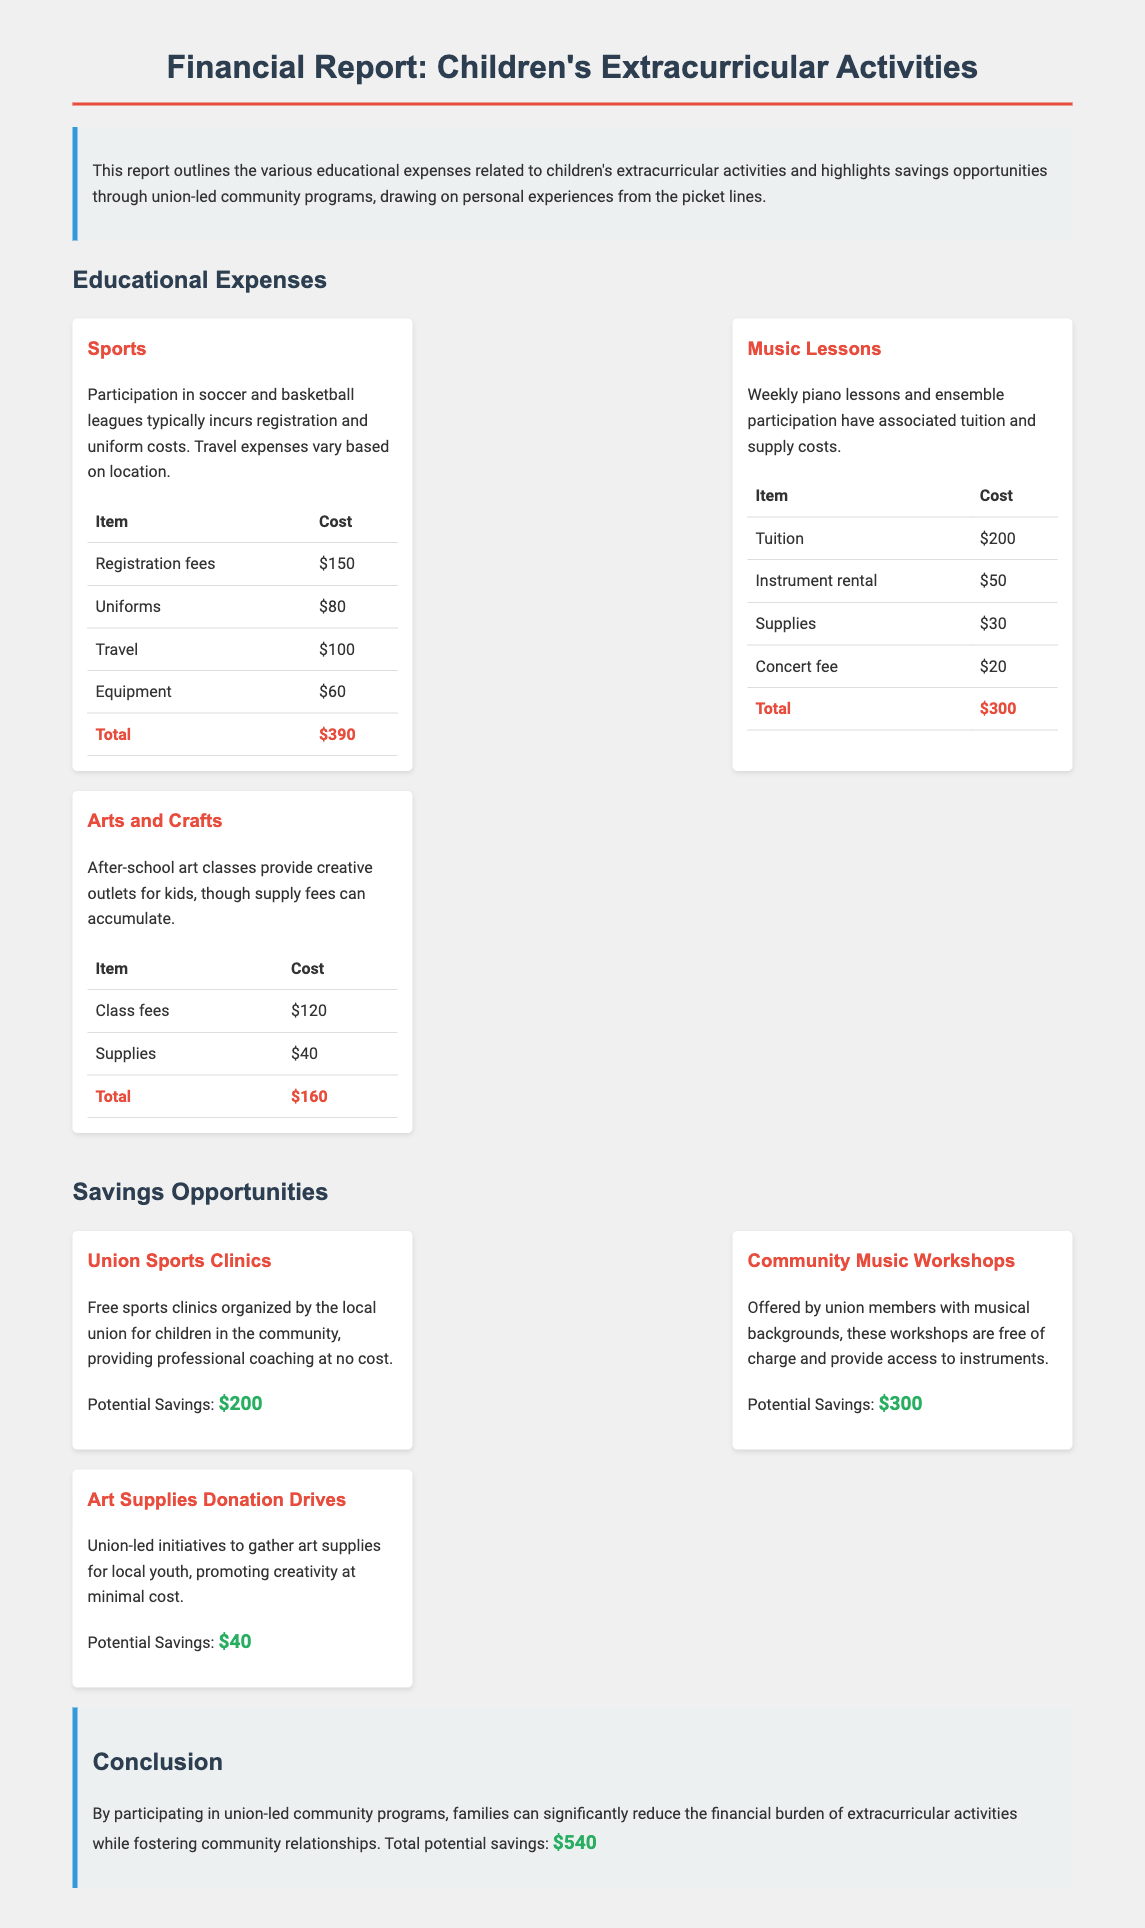What is the total cost for sports activities? The total cost for sports activities is detailed in the expenses section, which sums to $390.
Answer: $390 How much can families save from the Community Music Workshops? The potential savings from the Community Music Workshops is listed as $300.
Answer: $300 What item contributes the most to music lessons expenses? Among the listed items for music lessons, the tuition of $200 is the highest cost.
Answer: Tuition What initiative provides free professional coaching for children? Union Sports Clinics are specifically mentioned as providing free professional coaching for children.
Answer: Union Sports Clinics What is the potential total savings from all union-led programs? The document summarizes the total potential savings available through community programs as $540.
Answer: $540 What are the supplies needed for arts and crafts activities? The listed supplies costs in arts and crafts include $40 for supplies.
Answer: Supplies Which organization is responsible for the Art Supplies Donation Drives? The Art Supplies Donation Drives are organized by the union.
Answer: Union What activity has the lowest total cost among the extracurricular activities? The total cost for arts and crafts activities is the least, totaling $160.
Answer: $160 What is the registration fee for sports participation? The registration fee for sports is stated as $150 in the expenses section.
Answer: $150 